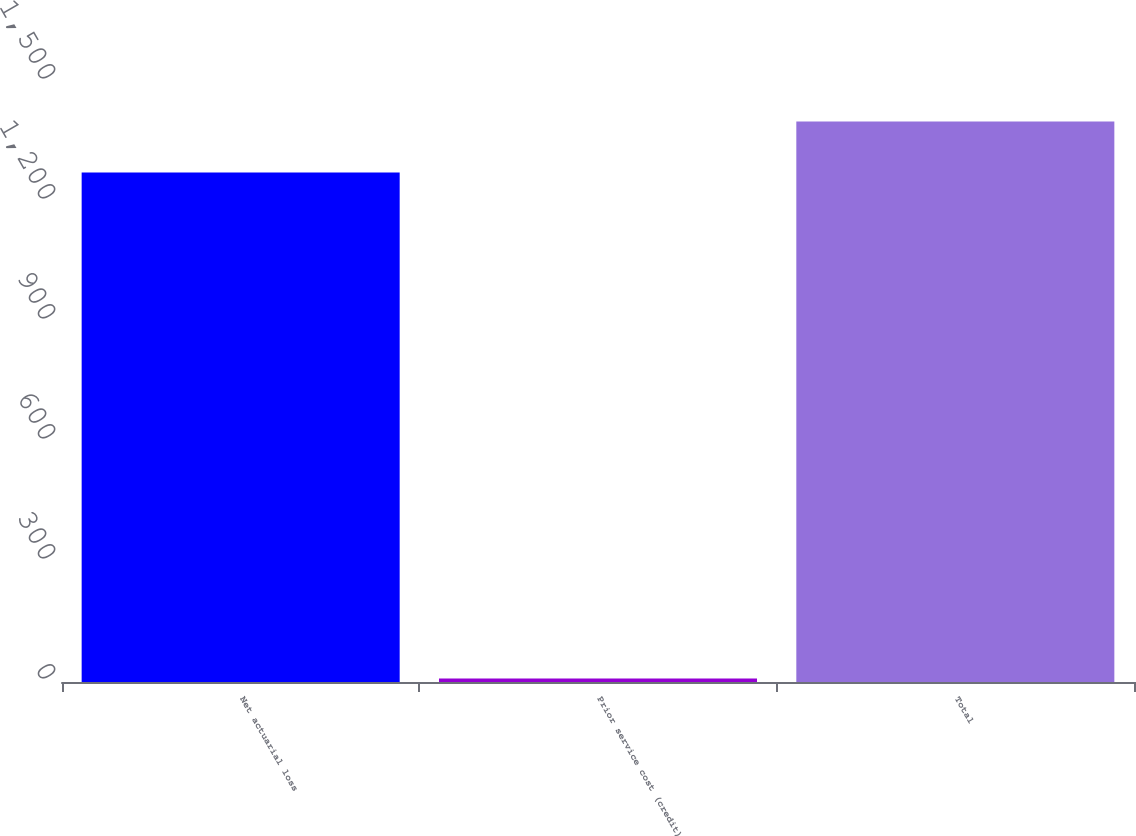<chart> <loc_0><loc_0><loc_500><loc_500><bar_chart><fcel>Net actuarial loss<fcel>Prior service cost (credit)<fcel>Total<nl><fcel>1273.6<fcel>8.5<fcel>1400.96<nl></chart> 